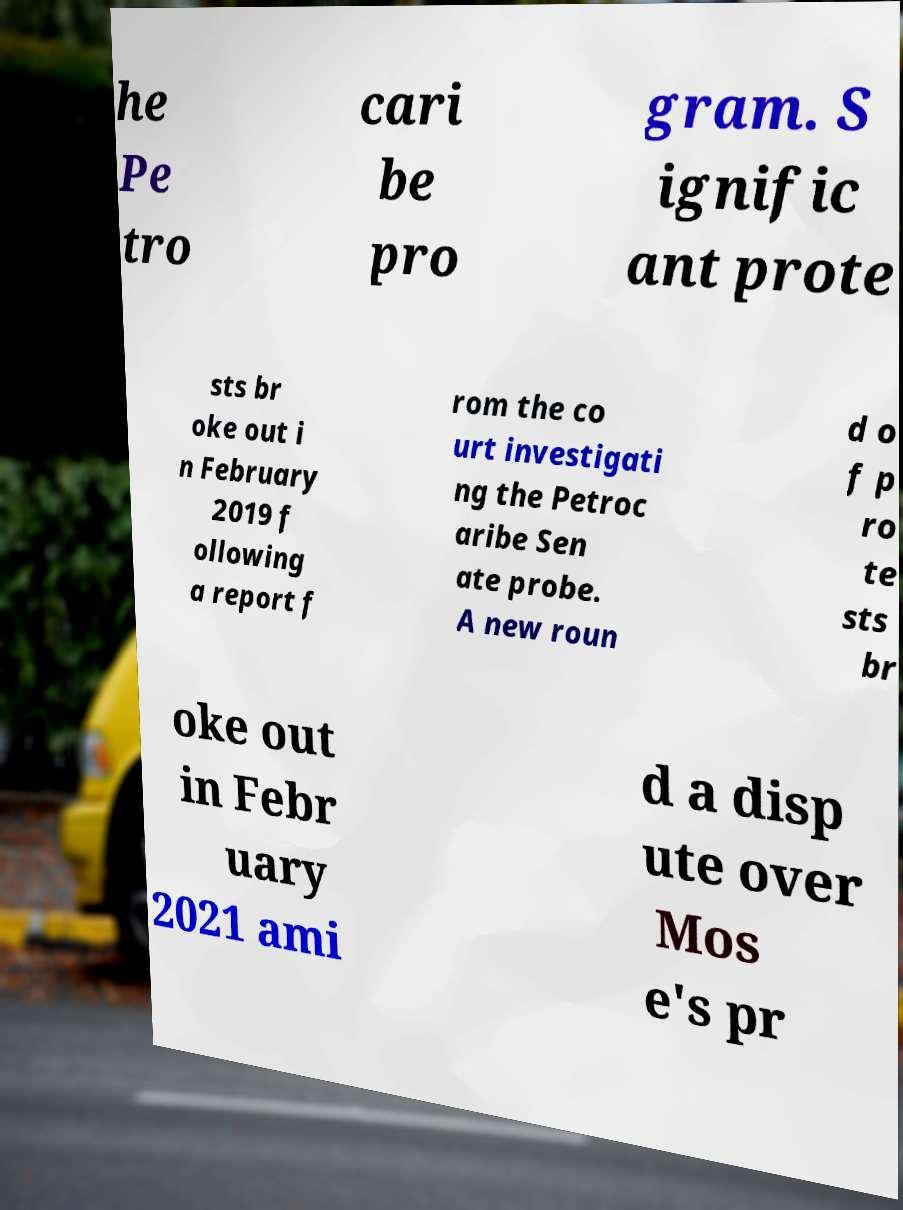What messages or text are displayed in this image? I need them in a readable, typed format. he Pe tro cari be pro gram. S ignific ant prote sts br oke out i n February 2019 f ollowing a report f rom the co urt investigati ng the Petroc aribe Sen ate probe. A new roun d o f p ro te sts br oke out in Febr uary 2021 ami d a disp ute over Mos e's pr 